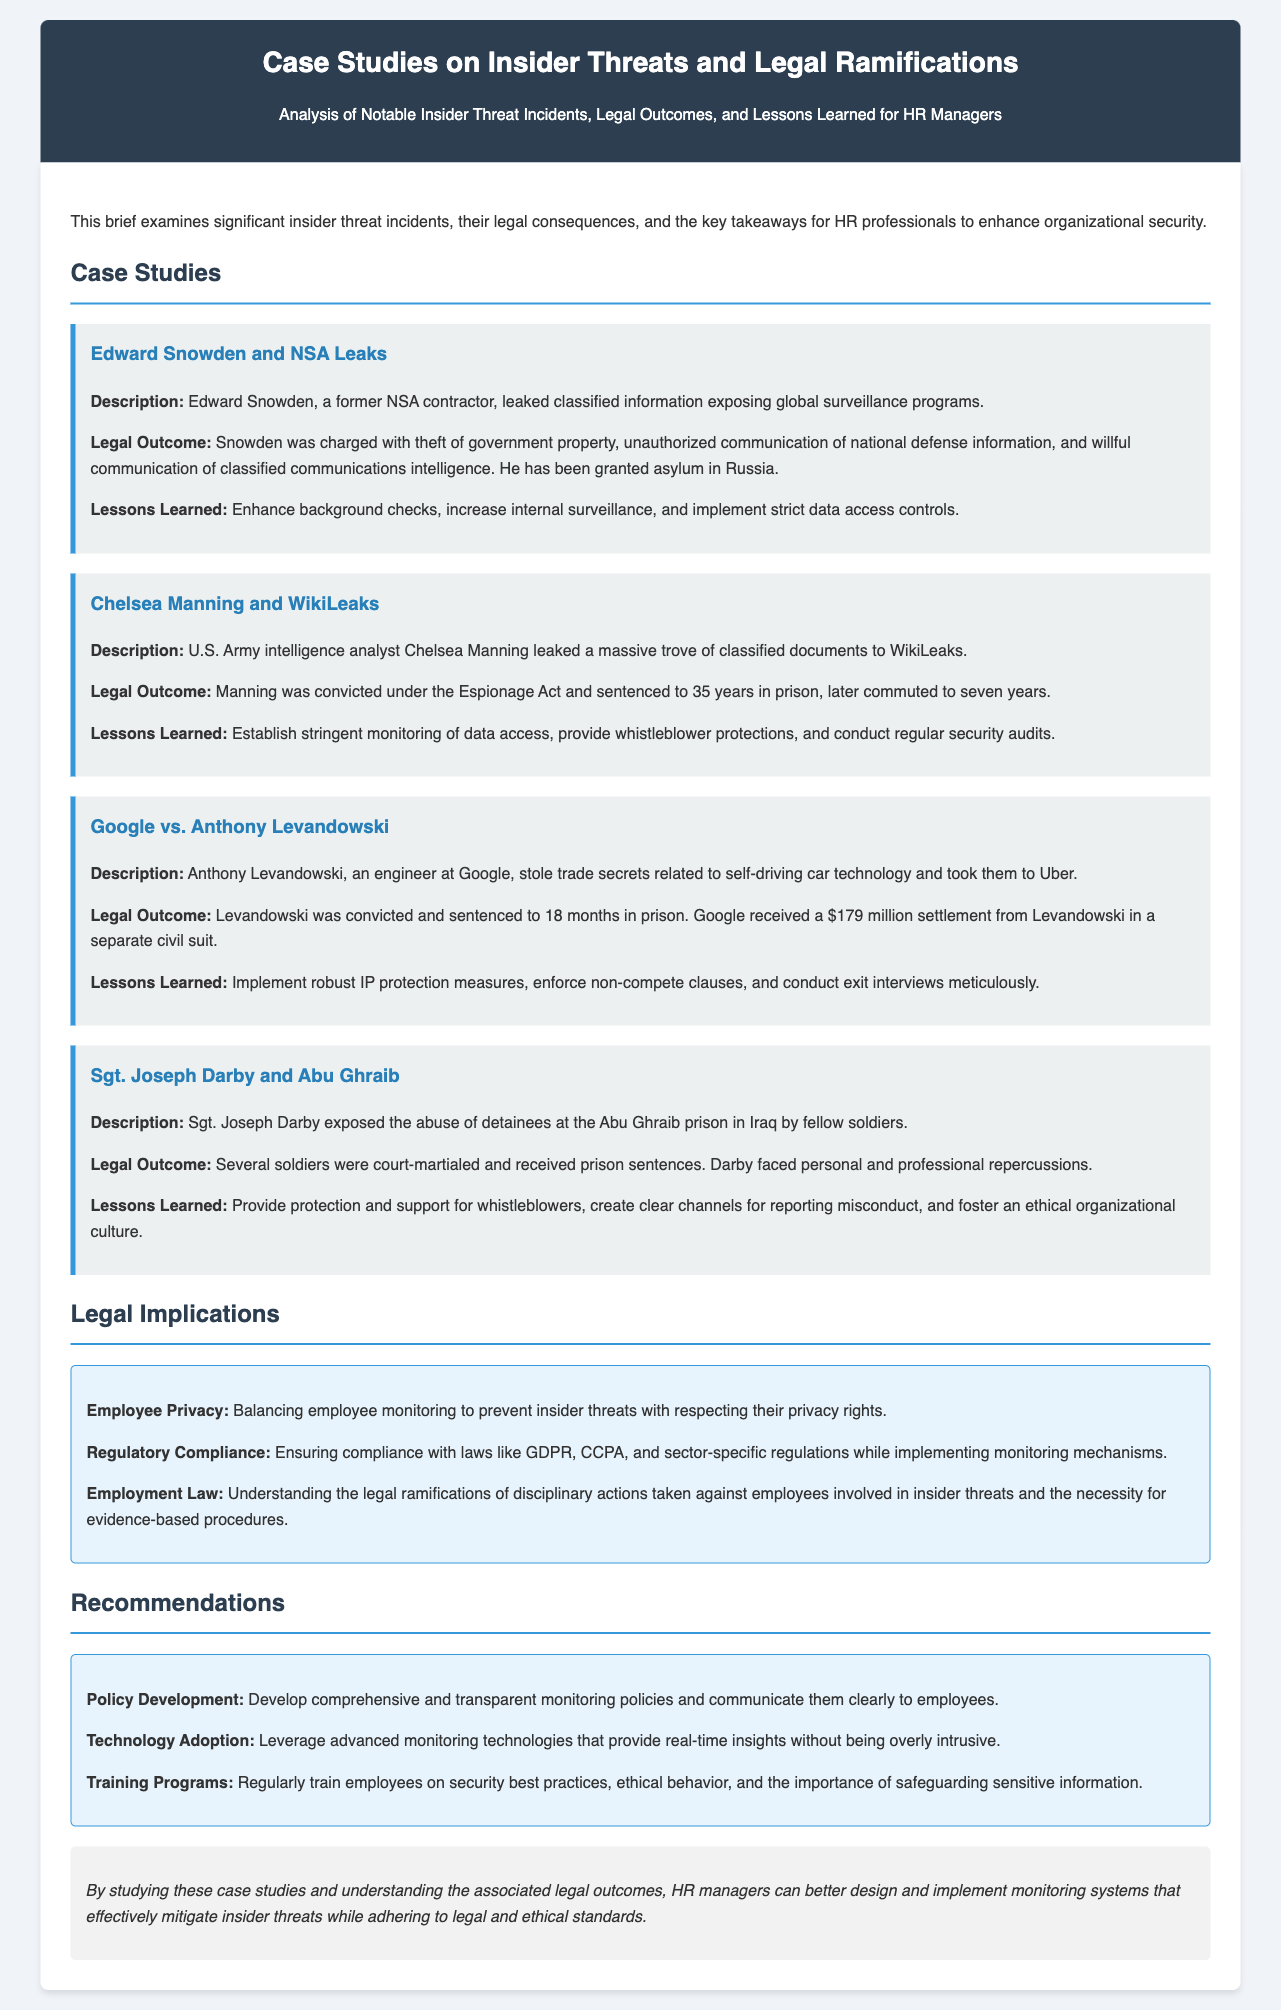What was Edward Snowden charged with? Edward Snowden was charged with theft of government property, unauthorized communication of national defense information, and willful communication of classified communications intelligence.
Answer: Theft of government property, unauthorized communication of national defense information, willful communication of classified communications intelligence How long was Chelsea Manning initially sentenced to prison? Chelsea Manning was convicted under the Espionage Act and sentenced to 35 years in prison.
Answer: 35 years What did Anthony Levandowski steal? Anthony Levandowski stole trade secrets related to self-driving car technology.
Answer: Trade secrets related to self-driving car technology What is one lesson learned from the Sgt. Joseph Darby case? One lesson learned from the Sgt. Joseph Darby case is to provide protection and support for whistleblowers.
Answer: Provide protection and support for whistleblowers What key aspect is crucial for employer monitoring mentioned in the legal implications? Balancing employee monitoring to prevent insider threats with respecting their privacy rights.
Answer: Balancing employee monitoring with privacy rights What recommendation is given for technology adoption? Leverage advanced monitoring technologies that provide real-time insights without being overly intrusive.
Answer: Leverage advanced monitoring technologies What legal act was Chelsea Manning convicted under? Chelsea Manning was convicted under the Espionage Act.
Answer: Espionage Act What should HR managers develop according to the recommendations? Develop comprehensive and transparent monitoring policies and communicate them clearly to employees.
Answer: Comprehensive and transparent monitoring policies 